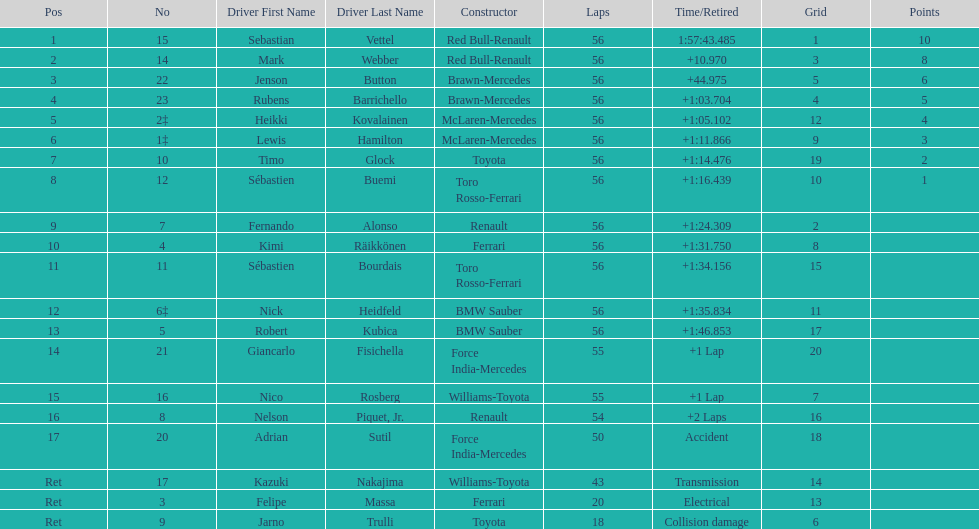Heikki kovalainen and lewis hamilton both had which constructor? McLaren-Mercedes. 